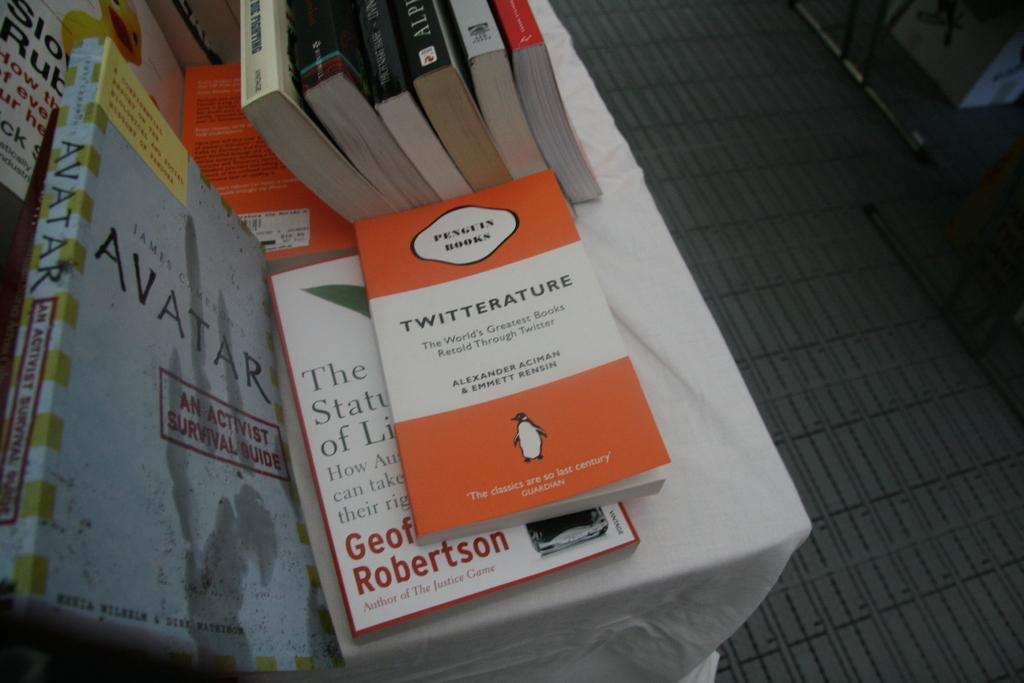<image>
Share a concise interpretation of the image provided. A number of books are on a table, incluidng Twitterature published by Penguin Books. 